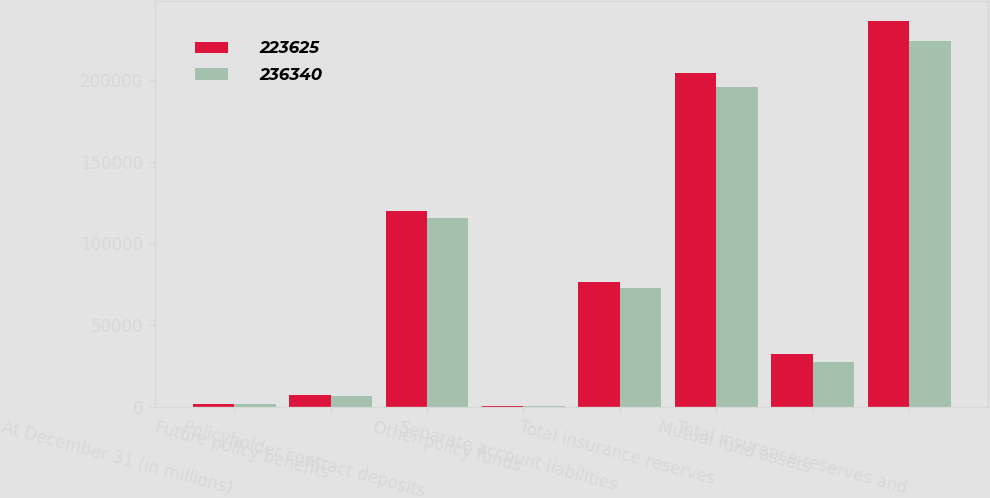<chart> <loc_0><loc_0><loc_500><loc_500><stacked_bar_chart><ecel><fcel>At December 31 (in millions)<fcel>Future policy benefits<fcel>Policyholder contract deposits<fcel>Other policy funds<fcel>Separate account liabilities<fcel>Total insurance reserves<fcel>Mutual fund assets<fcel>Total insurance reserves and<nl><fcel>223625<fcel>2016<fcel>7380<fcel>119644<fcel>378<fcel>76619<fcel>204021<fcel>32319<fcel>236340<nl><fcel>236340<fcel>2015<fcel>6945<fcel>115575<fcel>398<fcel>72972<fcel>195890<fcel>27735<fcel>223625<nl></chart> 